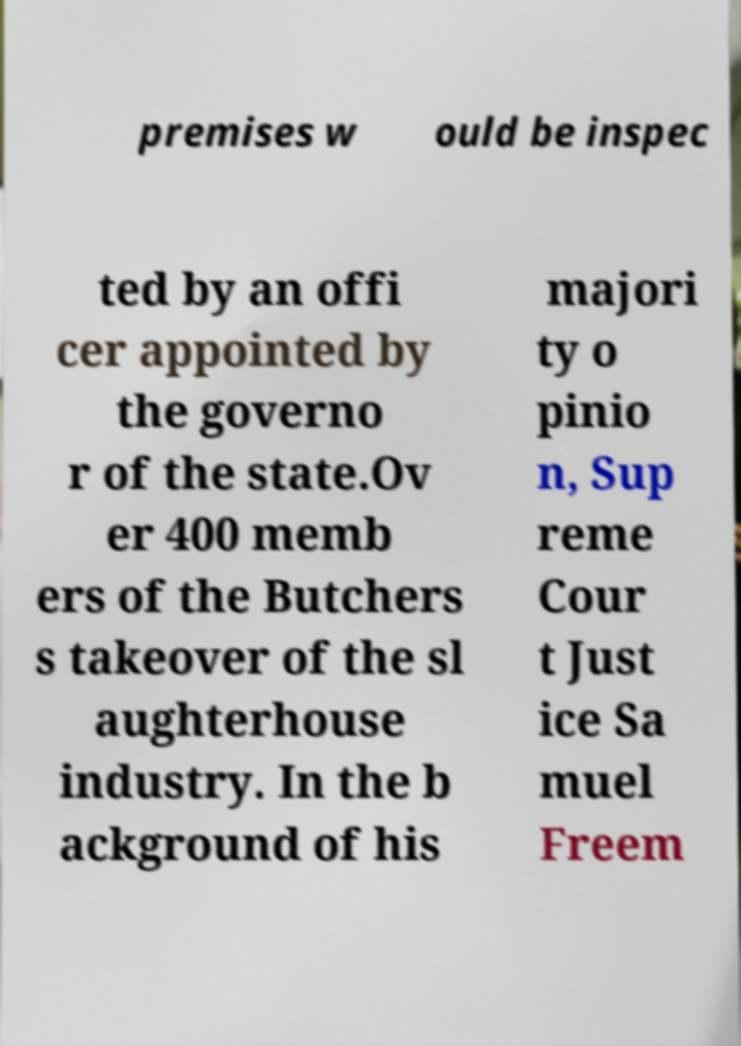There's text embedded in this image that I need extracted. Can you transcribe it verbatim? premises w ould be inspec ted by an offi cer appointed by the governo r of the state.Ov er 400 memb ers of the Butchers s takeover of the sl aughterhouse industry. In the b ackground of his majori ty o pinio n, Sup reme Cour t Just ice Sa muel Freem 